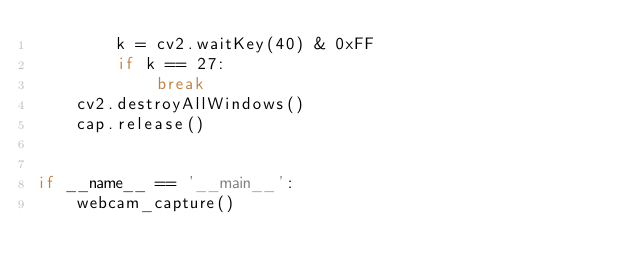<code> <loc_0><loc_0><loc_500><loc_500><_Python_>        k = cv2.waitKey(40) & 0xFF
        if k == 27:
            break
    cv2.destroyAllWindows()
    cap.release()


if __name__ == '__main__':
    webcam_capture()
</code> 